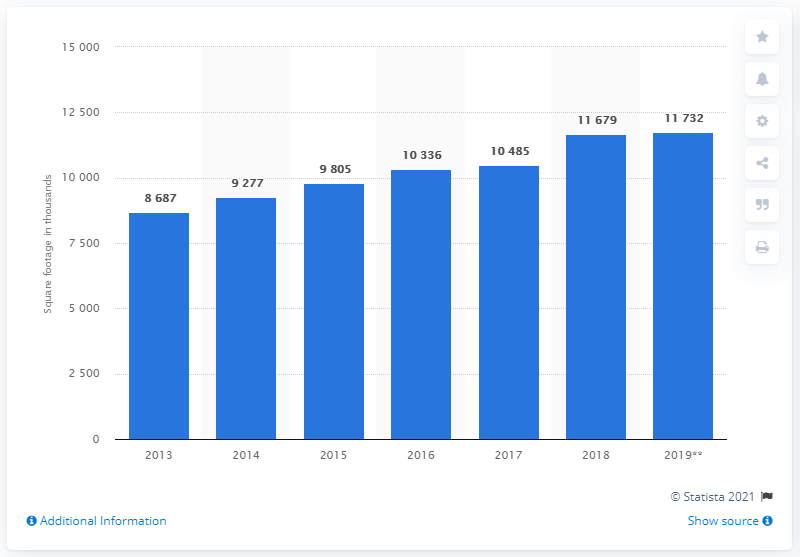Indicate a few pertinent items in this graphic. In 2019, the square footage of DSW stores was approximately 11,732 square feet. 